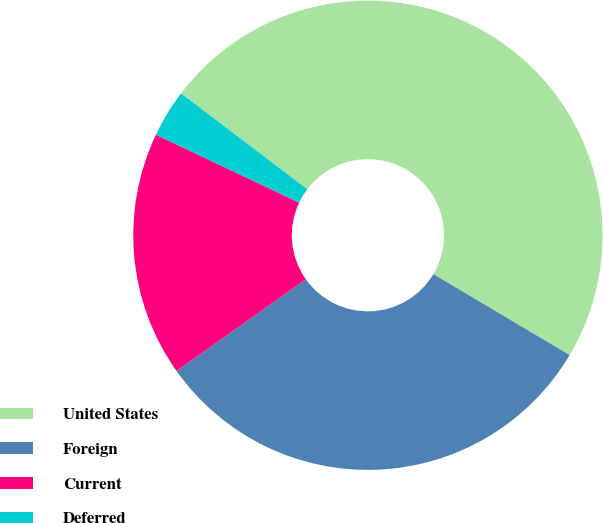Convert chart. <chart><loc_0><loc_0><loc_500><loc_500><pie_chart><fcel>United States<fcel>Foreign<fcel>Current<fcel>Deferred<nl><fcel>48.2%<fcel>31.65%<fcel>16.87%<fcel>3.28%<nl></chart> 